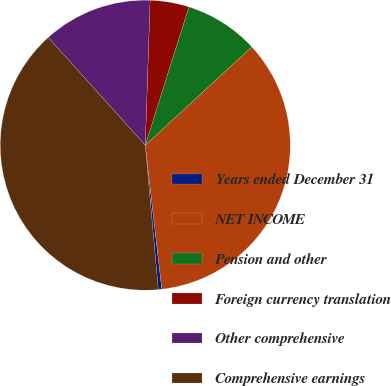Convert chart. <chart><loc_0><loc_0><loc_500><loc_500><pie_chart><fcel>Years ended December 31<fcel>NET INCOME<fcel>Pension and other<fcel>Foreign currency translation<fcel>Other comprehensive<fcel>Comprehensive earnings<nl><fcel>0.39%<fcel>35.04%<fcel>8.27%<fcel>4.33%<fcel>12.2%<fcel>39.76%<nl></chart> 